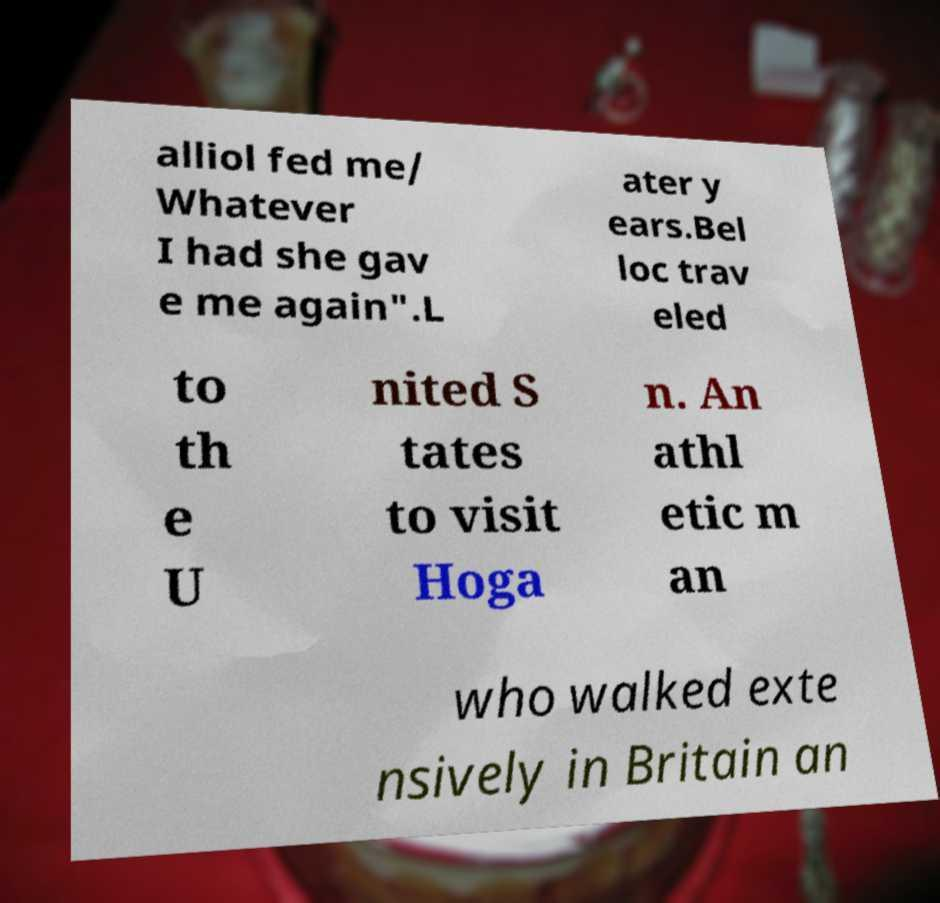Can you accurately transcribe the text from the provided image for me? alliol fed me/ Whatever I had she gav e me again".L ater y ears.Bel loc trav eled to th e U nited S tates to visit Hoga n. An athl etic m an who walked exte nsively in Britain an 